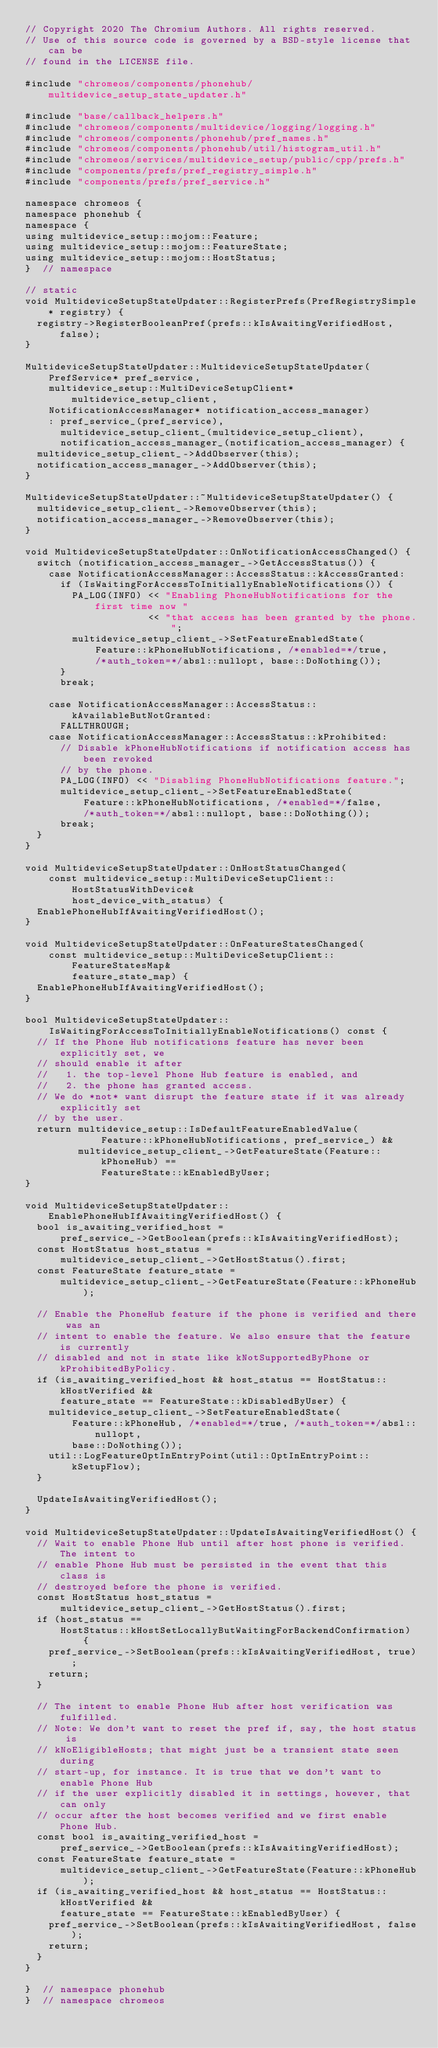Convert code to text. <code><loc_0><loc_0><loc_500><loc_500><_C++_>// Copyright 2020 The Chromium Authors. All rights reserved.
// Use of this source code is governed by a BSD-style license that can be
// found in the LICENSE file.

#include "chromeos/components/phonehub/multidevice_setup_state_updater.h"

#include "base/callback_helpers.h"
#include "chromeos/components/multidevice/logging/logging.h"
#include "chromeos/components/phonehub/pref_names.h"
#include "chromeos/components/phonehub/util/histogram_util.h"
#include "chromeos/services/multidevice_setup/public/cpp/prefs.h"
#include "components/prefs/pref_registry_simple.h"
#include "components/prefs/pref_service.h"

namespace chromeos {
namespace phonehub {
namespace {
using multidevice_setup::mojom::Feature;
using multidevice_setup::mojom::FeatureState;
using multidevice_setup::mojom::HostStatus;
}  // namespace

// static
void MultideviceSetupStateUpdater::RegisterPrefs(PrefRegistrySimple* registry) {
  registry->RegisterBooleanPref(prefs::kIsAwaitingVerifiedHost, false);
}

MultideviceSetupStateUpdater::MultideviceSetupStateUpdater(
    PrefService* pref_service,
    multidevice_setup::MultiDeviceSetupClient* multidevice_setup_client,
    NotificationAccessManager* notification_access_manager)
    : pref_service_(pref_service),
      multidevice_setup_client_(multidevice_setup_client),
      notification_access_manager_(notification_access_manager) {
  multidevice_setup_client_->AddObserver(this);
  notification_access_manager_->AddObserver(this);
}

MultideviceSetupStateUpdater::~MultideviceSetupStateUpdater() {
  multidevice_setup_client_->RemoveObserver(this);
  notification_access_manager_->RemoveObserver(this);
}

void MultideviceSetupStateUpdater::OnNotificationAccessChanged() {
  switch (notification_access_manager_->GetAccessStatus()) {
    case NotificationAccessManager::AccessStatus::kAccessGranted:
      if (IsWaitingForAccessToInitiallyEnableNotifications()) {
        PA_LOG(INFO) << "Enabling PhoneHubNotifications for the first time now "
                     << "that access has been granted by the phone.";
        multidevice_setup_client_->SetFeatureEnabledState(
            Feature::kPhoneHubNotifications, /*enabled=*/true,
            /*auth_token=*/absl::nullopt, base::DoNothing());
      }
      break;

    case NotificationAccessManager::AccessStatus::kAvailableButNotGranted:
      FALLTHROUGH;
    case NotificationAccessManager::AccessStatus::kProhibited:
      // Disable kPhoneHubNotifications if notification access has been revoked
      // by the phone.
      PA_LOG(INFO) << "Disabling PhoneHubNotifications feature.";
      multidevice_setup_client_->SetFeatureEnabledState(
          Feature::kPhoneHubNotifications, /*enabled=*/false,
          /*auth_token=*/absl::nullopt, base::DoNothing());
      break;
  }
}

void MultideviceSetupStateUpdater::OnHostStatusChanged(
    const multidevice_setup::MultiDeviceSetupClient::HostStatusWithDevice&
        host_device_with_status) {
  EnablePhoneHubIfAwaitingVerifiedHost();
}

void MultideviceSetupStateUpdater::OnFeatureStatesChanged(
    const multidevice_setup::MultiDeviceSetupClient::FeatureStatesMap&
        feature_state_map) {
  EnablePhoneHubIfAwaitingVerifiedHost();
}

bool MultideviceSetupStateUpdater::
    IsWaitingForAccessToInitiallyEnableNotifications() const {
  // If the Phone Hub notifications feature has never been explicitly set, we
  // should enable it after
  //   1. the top-level Phone Hub feature is enabled, and
  //   2. the phone has granted access.
  // We do *not* want disrupt the feature state if it was already explicitly set
  // by the user.
  return multidevice_setup::IsDefaultFeatureEnabledValue(
             Feature::kPhoneHubNotifications, pref_service_) &&
         multidevice_setup_client_->GetFeatureState(Feature::kPhoneHub) ==
             FeatureState::kEnabledByUser;
}

void MultideviceSetupStateUpdater::EnablePhoneHubIfAwaitingVerifiedHost() {
  bool is_awaiting_verified_host =
      pref_service_->GetBoolean(prefs::kIsAwaitingVerifiedHost);
  const HostStatus host_status =
      multidevice_setup_client_->GetHostStatus().first;
  const FeatureState feature_state =
      multidevice_setup_client_->GetFeatureState(Feature::kPhoneHub);

  // Enable the PhoneHub feature if the phone is verified and there was an
  // intent to enable the feature. We also ensure that the feature is currently
  // disabled and not in state like kNotSupportedByPhone or kProhibitedByPolicy.
  if (is_awaiting_verified_host && host_status == HostStatus::kHostVerified &&
      feature_state == FeatureState::kDisabledByUser) {
    multidevice_setup_client_->SetFeatureEnabledState(
        Feature::kPhoneHub, /*enabled=*/true, /*auth_token=*/absl::nullopt,
        base::DoNothing());
    util::LogFeatureOptInEntryPoint(util::OptInEntryPoint::kSetupFlow);
  }

  UpdateIsAwaitingVerifiedHost();
}

void MultideviceSetupStateUpdater::UpdateIsAwaitingVerifiedHost() {
  // Wait to enable Phone Hub until after host phone is verified. The intent to
  // enable Phone Hub must be persisted in the event that this class is
  // destroyed before the phone is verified.
  const HostStatus host_status =
      multidevice_setup_client_->GetHostStatus().first;
  if (host_status ==
      HostStatus::kHostSetLocallyButWaitingForBackendConfirmation) {
    pref_service_->SetBoolean(prefs::kIsAwaitingVerifiedHost, true);
    return;
  }

  // The intent to enable Phone Hub after host verification was fulfilled.
  // Note: We don't want to reset the pref if, say, the host status is
  // kNoEligibleHosts; that might just be a transient state seen during
  // start-up, for instance. It is true that we don't want to enable Phone Hub
  // if the user explicitly disabled it in settings, however, that can only
  // occur after the host becomes verified and we first enable Phone Hub.
  const bool is_awaiting_verified_host =
      pref_service_->GetBoolean(prefs::kIsAwaitingVerifiedHost);
  const FeatureState feature_state =
      multidevice_setup_client_->GetFeatureState(Feature::kPhoneHub);
  if (is_awaiting_verified_host && host_status == HostStatus::kHostVerified &&
      feature_state == FeatureState::kEnabledByUser) {
    pref_service_->SetBoolean(prefs::kIsAwaitingVerifiedHost, false);
    return;
  }
}

}  // namespace phonehub
}  // namespace chromeos
</code> 